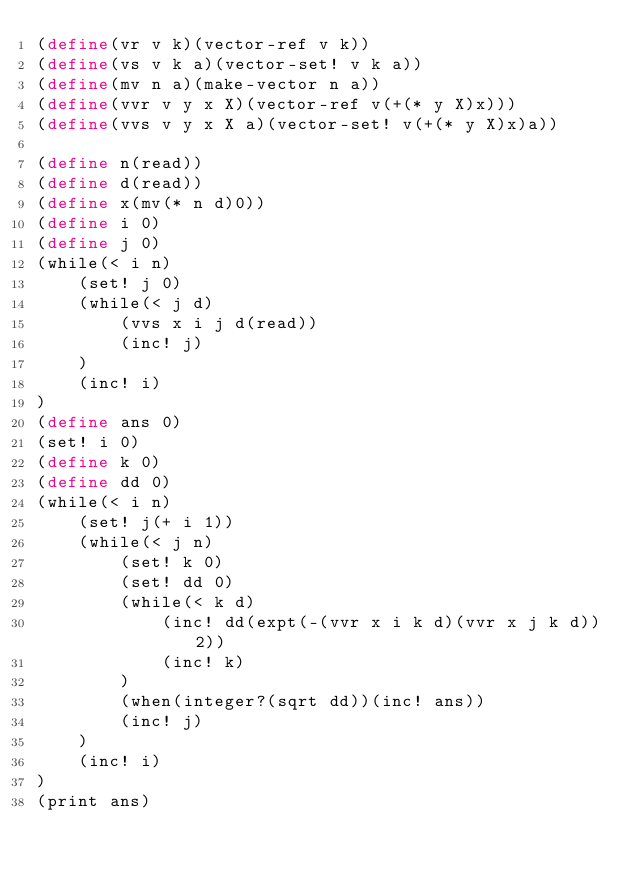Convert code to text. <code><loc_0><loc_0><loc_500><loc_500><_Scheme_>(define(vr v k)(vector-ref v k))
(define(vs v k a)(vector-set! v k a))
(define(mv n a)(make-vector n a))
(define(vvr v y x X)(vector-ref v(+(* y X)x)))
(define(vvs v y x X a)(vector-set! v(+(* y X)x)a))

(define n(read))
(define d(read))
(define x(mv(* n d)0))
(define i 0)
(define j 0)
(while(< i n)
	(set! j 0)
	(while(< j d)
		(vvs x i j d(read))
		(inc! j)
	)
	(inc! i)
)
(define ans 0)
(set! i 0)
(define k 0)
(define dd 0)
(while(< i n)
	(set! j(+ i 1))
	(while(< j n)
		(set! k 0)
		(set! dd 0)
		(while(< k d)
			(inc! dd(expt(-(vvr x i k d)(vvr x j k d))2))
			(inc! k)
		)
		(when(integer?(sqrt dd))(inc! ans))
		(inc! j)
	)
	(inc! i)
)
(print ans)</code> 